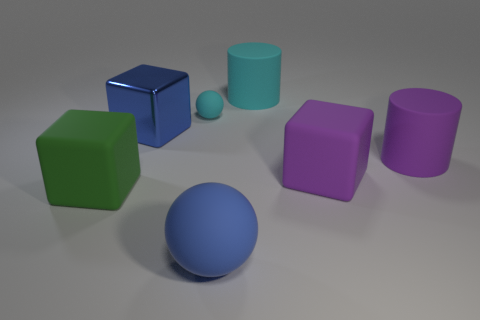What shape is the thing that is the same color as the large ball?
Provide a short and direct response. Cube. Are there more big green blocks that are behind the large cyan cylinder than small brown rubber spheres?
Your response must be concise. No. What number of rubber cubes have the same size as the purple matte cylinder?
Your response must be concise. 2. The metallic thing that is the same color as the big ball is what size?
Make the answer very short. Large. How many things are either big yellow rubber things or objects in front of the big cyan rubber cylinder?
Your response must be concise. 6. There is a big thing that is both in front of the cyan cylinder and behind the purple cylinder; what color is it?
Provide a succinct answer. Blue. Do the purple rubber block and the shiny thing have the same size?
Offer a terse response. Yes. What is the color of the large matte thing that is behind the tiny cyan object?
Offer a terse response. Cyan. Is there a large cylinder of the same color as the metallic cube?
Make the answer very short. No. The ball that is the same size as the green rubber thing is what color?
Ensure brevity in your answer.  Blue. 